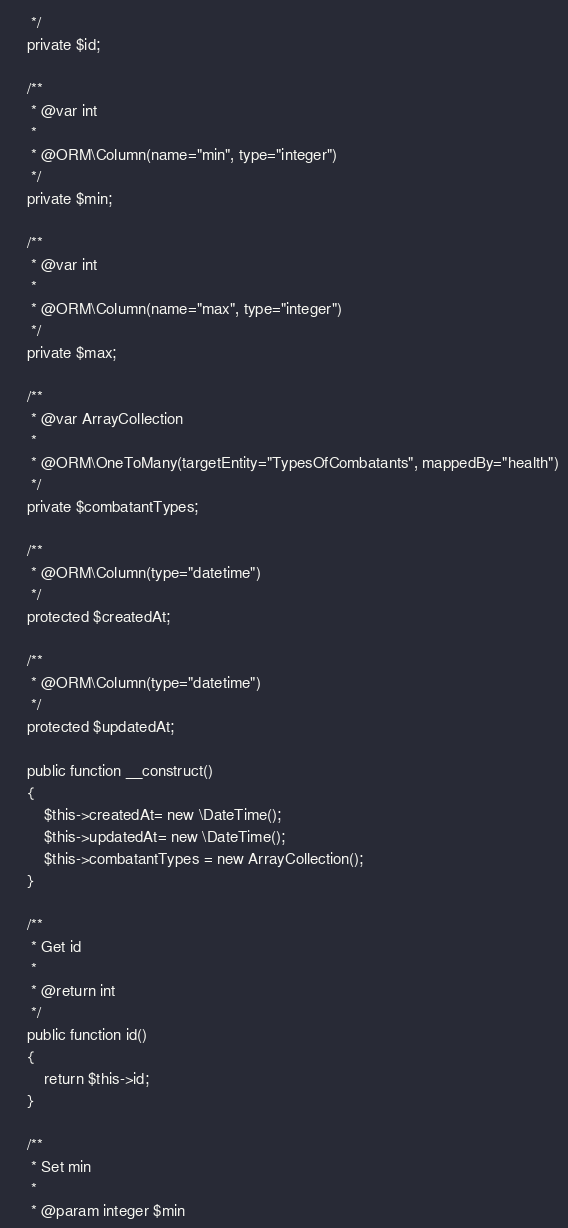Convert code to text. <code><loc_0><loc_0><loc_500><loc_500><_PHP_>     */
    private $id;

    /**
     * @var int
     *
     * @ORM\Column(name="min", type="integer")
     */
    private $min;

    /**
     * @var int
     *
     * @ORM\Column(name="max", type="integer")
     */
    private $max;

    /**
     * @var ArrayCollection
     *
     * @ORM\OneToMany(targetEntity="TypesOfCombatants", mappedBy="health")
     */
    private $combatantTypes;

    /**
     * @ORM\Column(type="datetime")
     */
    protected $createdAt;

    /**
     * @ORM\Column(type="datetime")
     */
    protected $updatedAt;

    public function __construct()
    {
        $this->createdAt= new \DateTime();
        $this->updatedAt= new \DateTime();
        $this->combatantTypes = new ArrayCollection();
    }

    /**
     * Get id
     *
     * @return int
     */
    public function id()
    {
        return $this->id;
    }

    /**
     * Set min
     *
     * @param integer $min</code> 